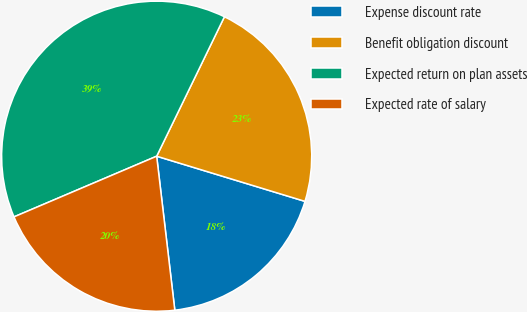<chart> <loc_0><loc_0><loc_500><loc_500><pie_chart><fcel>Expense discount rate<fcel>Benefit obligation discount<fcel>Expected return on plan assets<fcel>Expected rate of salary<nl><fcel>18.43%<fcel>22.51%<fcel>38.6%<fcel>20.47%<nl></chart> 